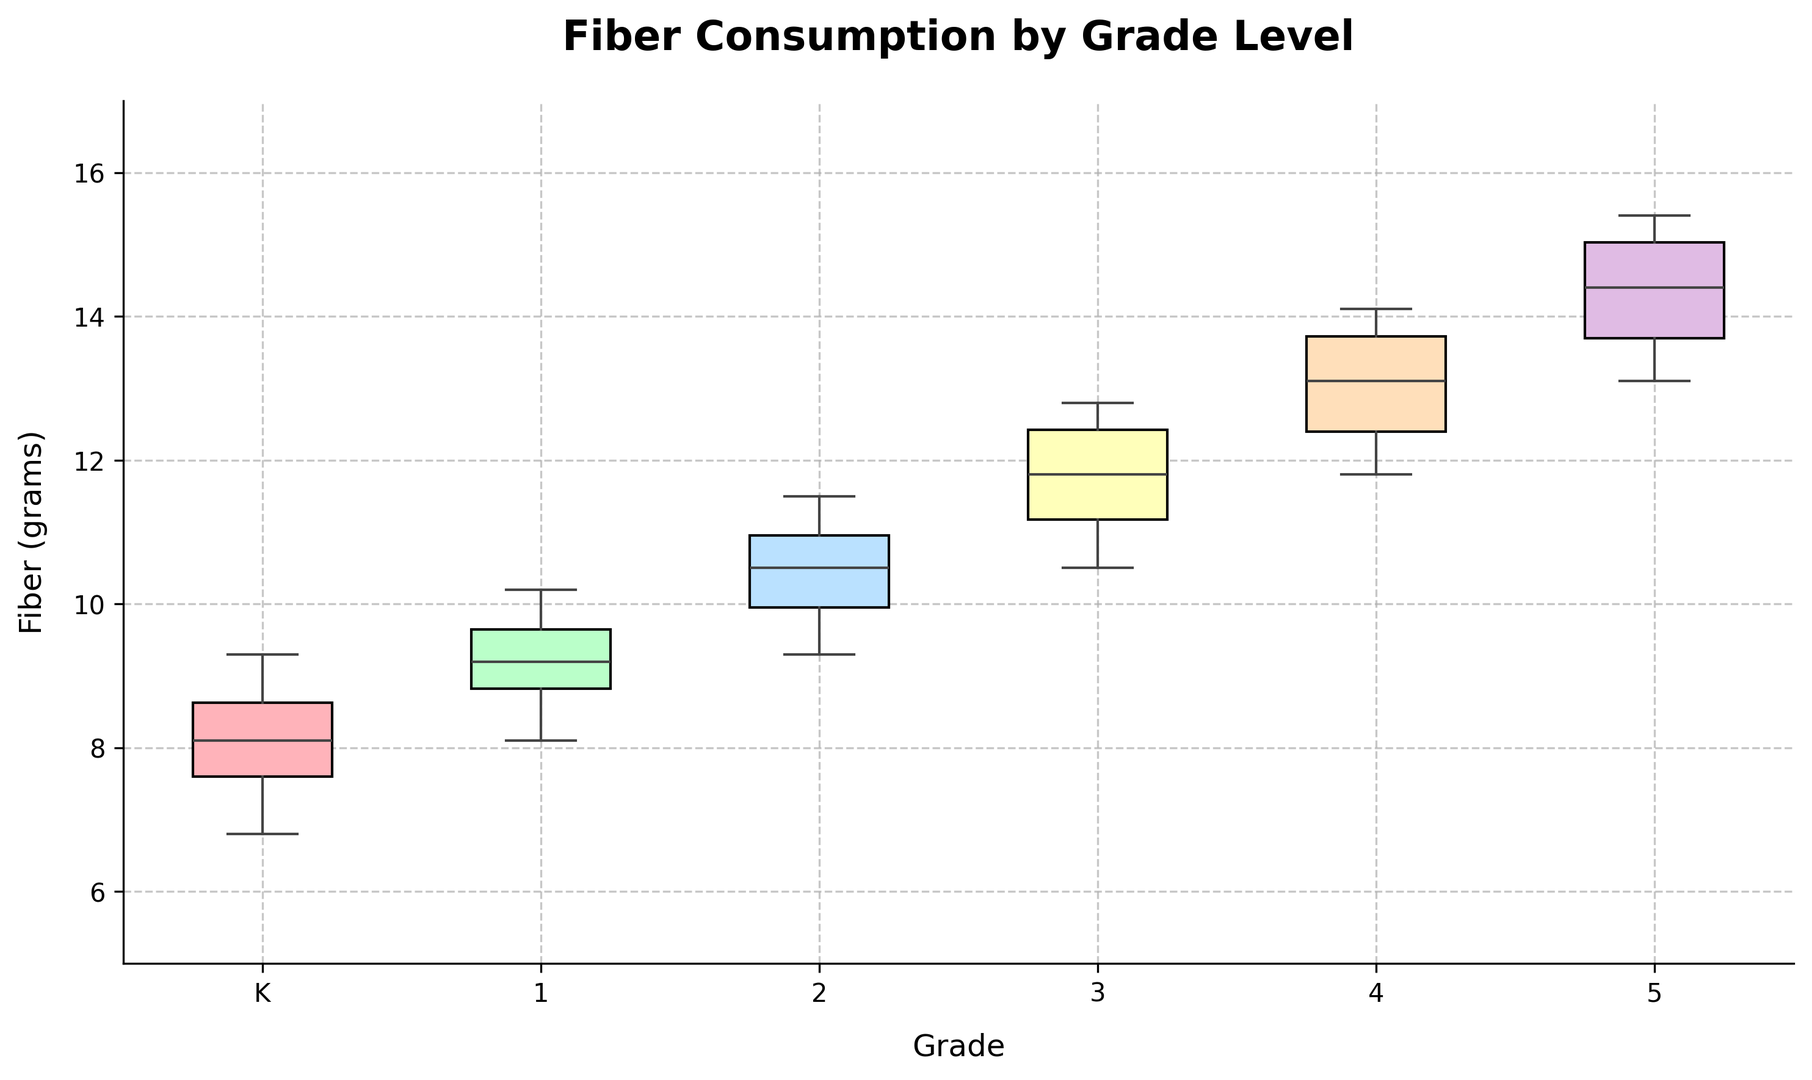What is the median fiber consumption for children in the 3rd grade? To find the median fiber consumption for 3rd graders, locate the box plot for grade 3 and identify the line inside the box, which represents the median value.
Answer: 11.95 grams Which grade has the highest median fiber consumption? Compare the median lines (the middle lines inside the boxes) for each grade. The highest median will be at the top among the middle lines.
Answer: 5th grade What is the interquartile range (IQR) of fiber consumption for 1st graders? The IQR is the difference between the third quartile (upper edge of the box) and the first quartile (lower edge of the box). Identify these edges on the box plot for 1st graders and subtract the lower from the upper.
Answer: 1.5 grams How does the fiber consumption of children in 2nd grade compare to those in kindergarten? Look at the position of the boxes for 2nd grade and kindergarten. Compare the median, quartiles, and overall spread. The box for 2nd grade is higher than kindergarten, indicating higher fiber consumption.
Answer: 2nd grade consumes more fiber than kindergarten Which grade shows the widest range of fiber consumption? The range is given by the difference between the maximum and minimum values, indicated by the ends of the whiskers. Identify the grade with the longest whisker span.
Answer: 4th grade What is the lowest fiber consumption value observed among all grades? Check the lowest whisker on the plot, which shows the minimum value across all grades.
Answer: 6.8 grams (kindergarten) What colors are used for the boxes for kindergarten and 3rd grade? Identify the colors filling the boxes for kindergarten and 3rd grade on the plot. Kindergarten is the first box on the left, and 3rd grade is the fourth box.
Answer: Kindergarten: Red, 3rd grade: Light blue Which grade has the smallest interquartile range (IQR) for fiber consumption? Compare the heights of the boxes for each grade. The grade with the shortest box has the smallest IQR.
Answer: Kindergarten Is there any overlap in the range of fiber consumption between 4th and 5th graders? Compare the whisker ranges (minimum to maximum) of the 4th and 5th grade boxes. If the whiskers overlap, there is an overlap in the range.
Answer: Yes, there is an overlap 